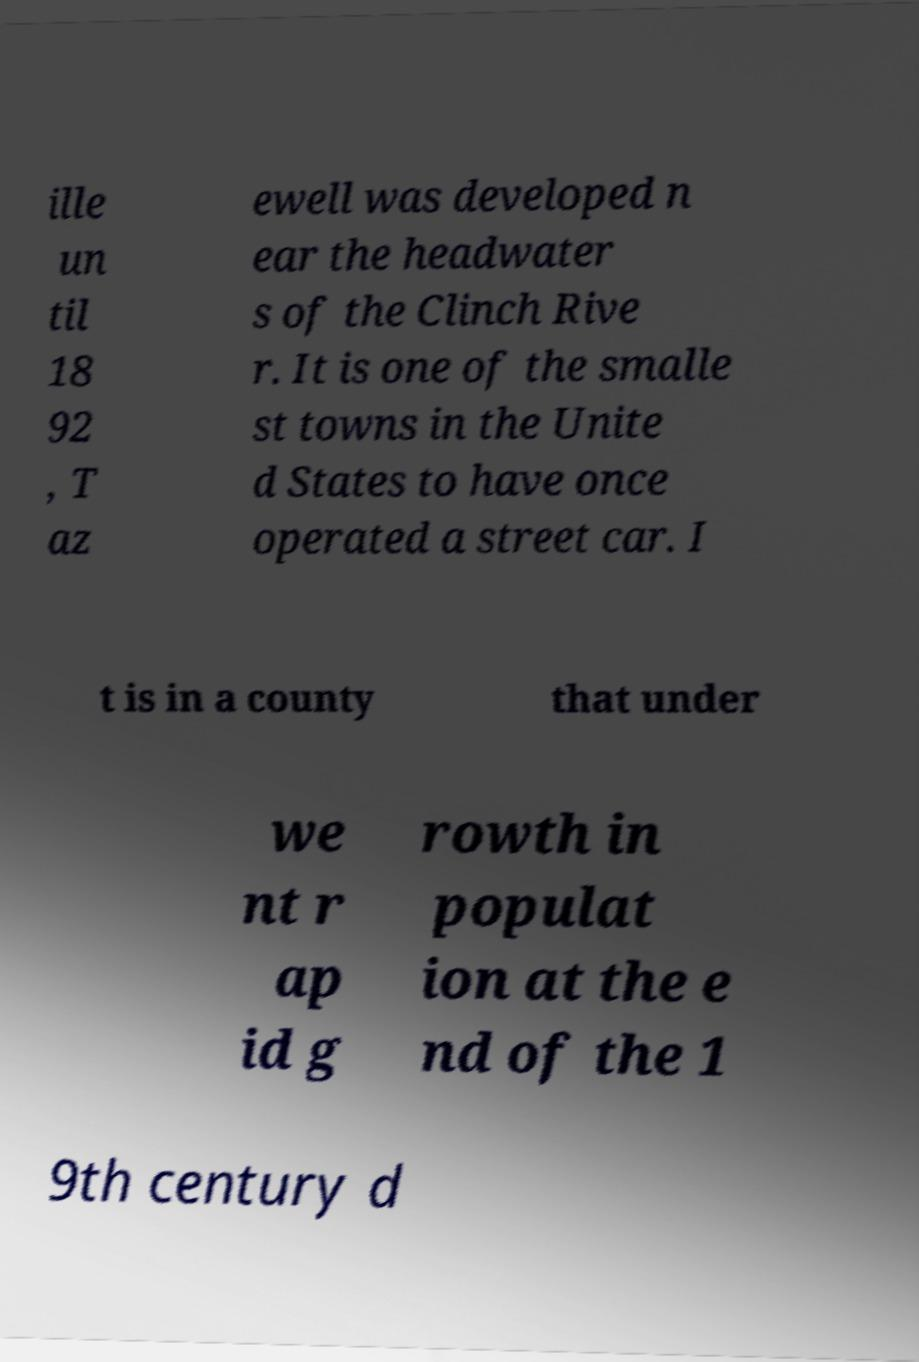Could you extract and type out the text from this image? ille un til 18 92 , T az ewell was developed n ear the headwater s of the Clinch Rive r. It is one of the smalle st towns in the Unite d States to have once operated a street car. I t is in a county that under we nt r ap id g rowth in populat ion at the e nd of the 1 9th century d 